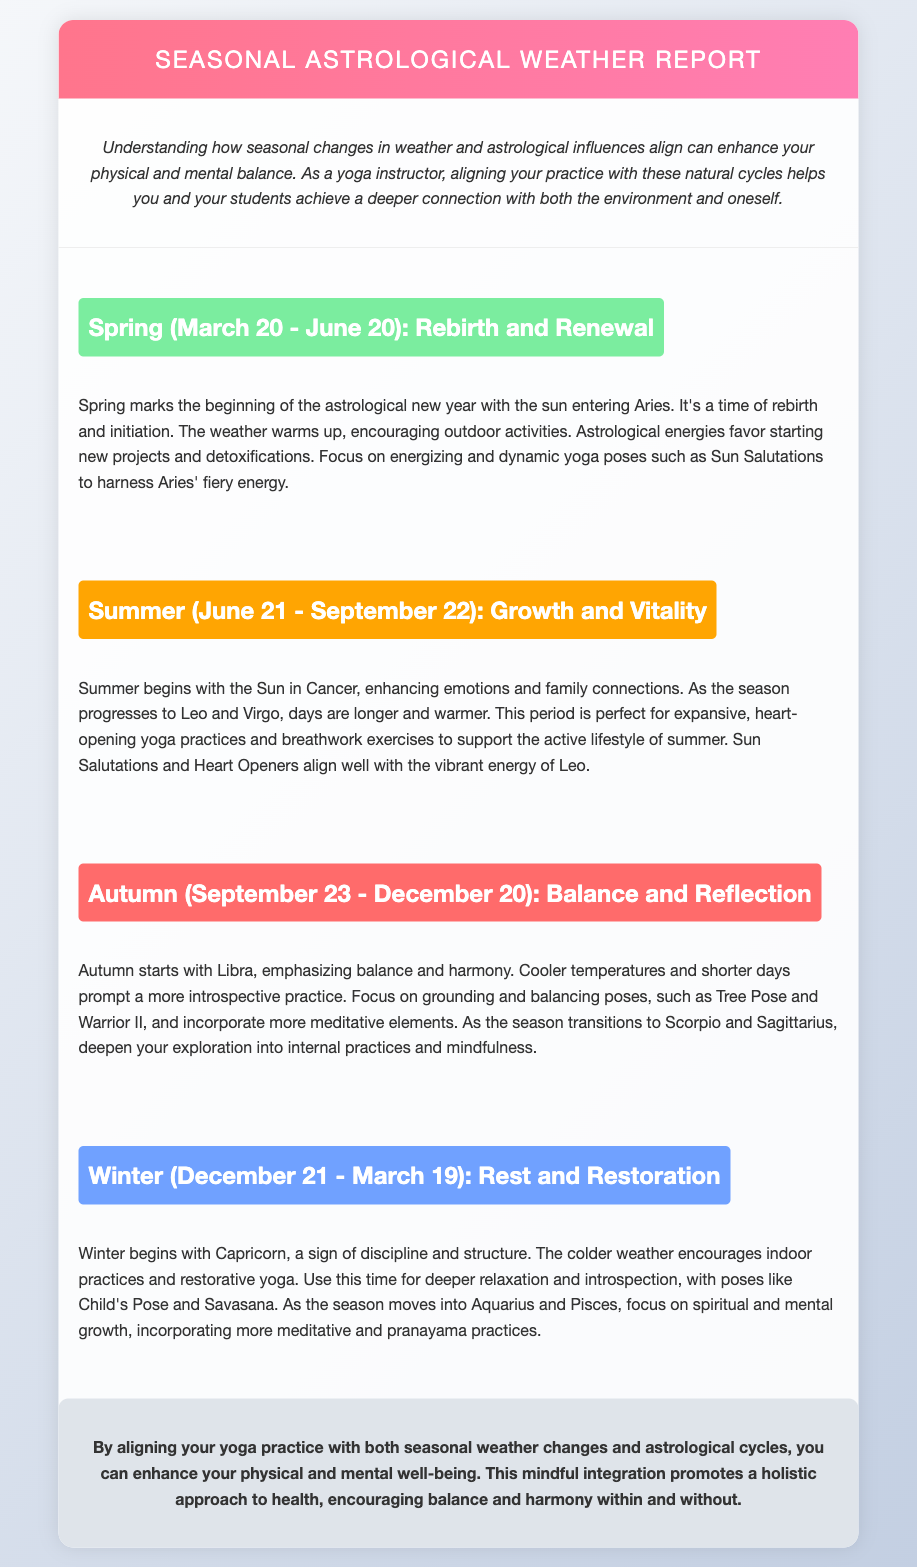what event marks the beginning of spring? Spring marks the beginning of the astrological new year with the sun entering Aries.
Answer: astrological new year what are the key yoga practices for summer? The document suggests expansive, heart-opening yoga practices and breathwork exercises to support the active lifestyle of summer.
Answer: expansive, heart-opening yoga practices which astrological sign starts autumn? Autumn starts with Libra, emphasizing balance and harmony.
Answer: Libra what is the focus of yoga during winter? The focus during winter is on deeper relaxation and introspection.
Answer: deeper relaxation and introspection how long does the summer season last? The document states that summer lasts from June 21 to September 22.
Answer: June 21 - September 22 what type of poses are recommended for spring? The document recommends energizing and dynamic yoga poses such as Sun Salutations to harness Aries' fiery energy.
Answer: Sun Salutations what theme is emphasized in autumn? Autumn emphasizes balance and harmony, as it starts with Libra.
Answer: balance and harmony which sign is associated with discipline and structure? Capricorn, which begins winter, is associated with discipline and structure.
Answer: Capricorn 